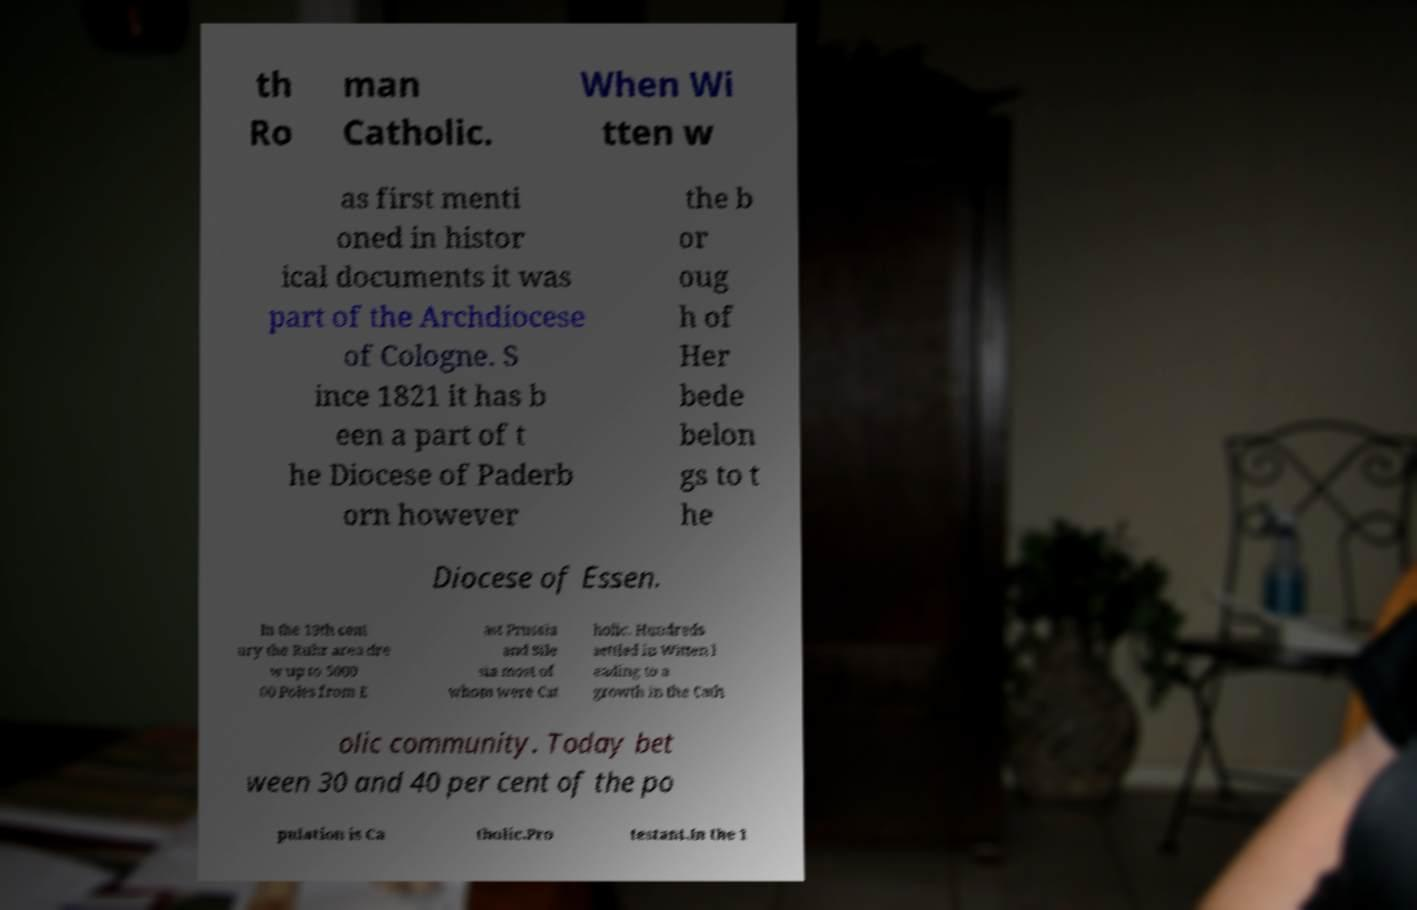Please read and relay the text visible in this image. What does it say? th Ro man Catholic. When Wi tten w as first menti oned in histor ical documents it was part of the Archdiocese of Cologne. S ince 1821 it has b een a part of t he Diocese of Paderb orn however the b or oug h of Her bede belon gs to t he Diocese of Essen. In the 19th cent ury the Ruhr area dre w up to 5000 00 Poles from E ast Prussia and Sile sia most of whom were Cat holic. Hundreds settled in Witten l eading to a growth in the Cath olic community. Today bet ween 30 and 40 per cent of the po pulation is Ca tholic.Pro testant.In the 1 